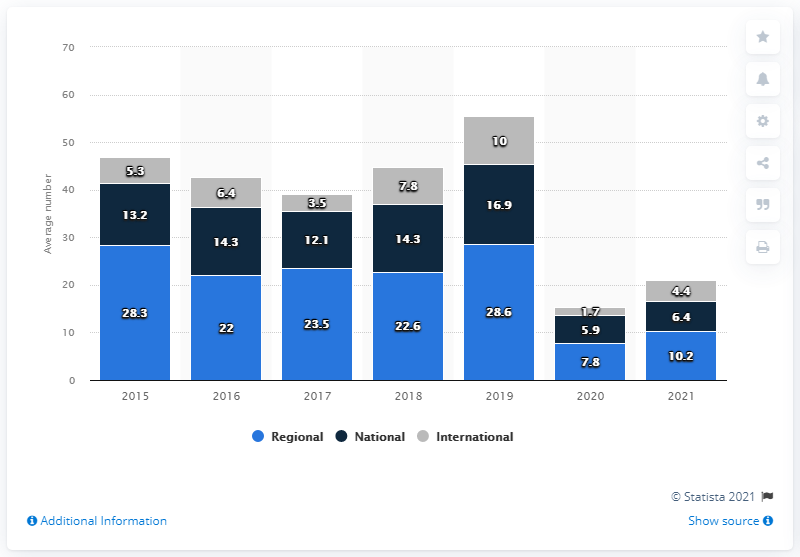Highlight a few significant elements in this photo. In 2021, the survey asked respondents about their plans for trade shows. In the year 2017, there were a total of 39.1 shows. The year with the least number of international trade shows is 2020. In 2020, industry professionals attended a total of 7.8 regional shows. 